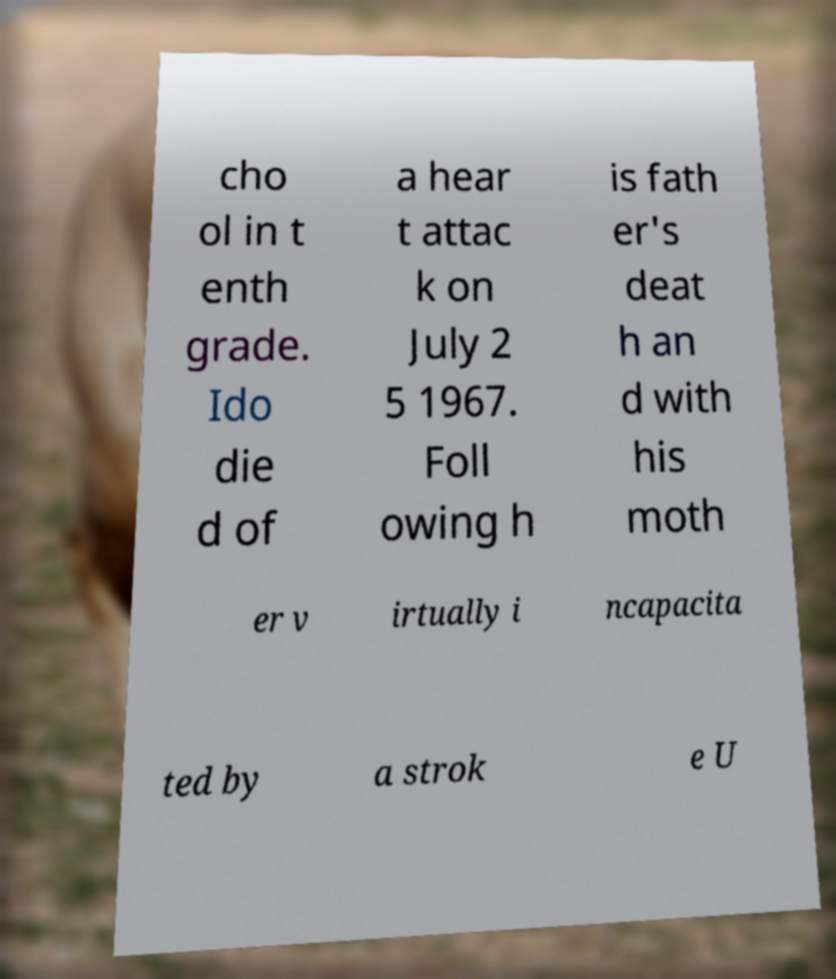Could you assist in decoding the text presented in this image and type it out clearly? cho ol in t enth grade. Ido die d of a hear t attac k on July 2 5 1967. Foll owing h is fath er's deat h an d with his moth er v irtually i ncapacita ted by a strok e U 